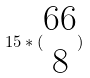Convert formula to latex. <formula><loc_0><loc_0><loc_500><loc_500>1 5 * ( \begin{matrix} 6 6 \\ 8 \end{matrix} )</formula> 